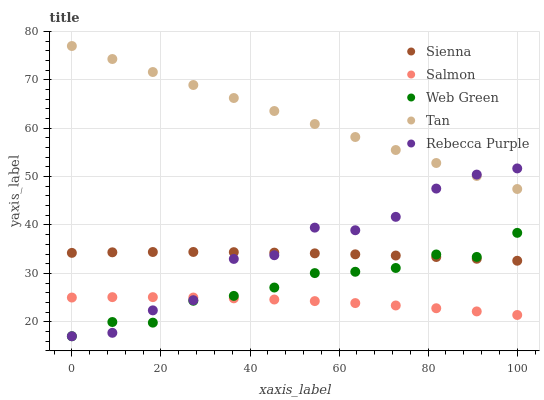Does Salmon have the minimum area under the curve?
Answer yes or no. Yes. Does Tan have the maximum area under the curve?
Answer yes or no. Yes. Does Tan have the minimum area under the curve?
Answer yes or no. No. Does Salmon have the maximum area under the curve?
Answer yes or no. No. Is Tan the smoothest?
Answer yes or no. Yes. Is Rebecca Purple the roughest?
Answer yes or no. Yes. Is Salmon the smoothest?
Answer yes or no. No. Is Salmon the roughest?
Answer yes or no. No. Does Rebecca Purple have the lowest value?
Answer yes or no. Yes. Does Salmon have the lowest value?
Answer yes or no. No. Does Tan have the highest value?
Answer yes or no. Yes. Does Salmon have the highest value?
Answer yes or no. No. Is Sienna less than Tan?
Answer yes or no. Yes. Is Tan greater than Web Green?
Answer yes or no. Yes. Does Sienna intersect Web Green?
Answer yes or no. Yes. Is Sienna less than Web Green?
Answer yes or no. No. Is Sienna greater than Web Green?
Answer yes or no. No. Does Sienna intersect Tan?
Answer yes or no. No. 